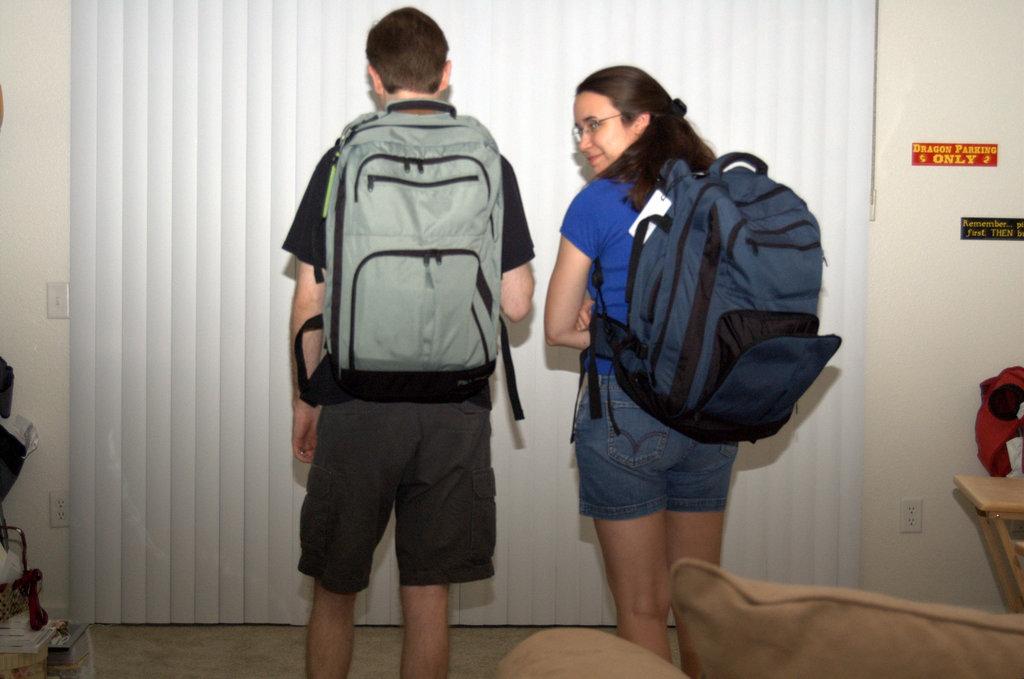What kind of parking is allowed?
Your answer should be very brief. Dragon. What does the sign say at the bottom?
Provide a succinct answer. Only. 